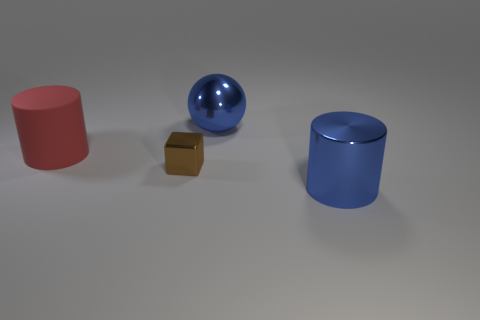There is a big metallic cylinder; is it the same color as the object behind the big red cylinder?
Make the answer very short. Yes. Is the color of the metal sphere the same as the shiny cylinder?
Offer a terse response. Yes. Is there any other thing that has the same size as the brown object?
Ensure brevity in your answer.  No. There is a big blue object that is in front of the blue object behind the large blue metallic object in front of the brown thing; what is its shape?
Your answer should be compact. Cylinder. How many other things are there of the same color as the big sphere?
Offer a terse response. 1. The large blue object on the left side of the blue object in front of the tiny brown metallic block is what shape?
Provide a short and direct response. Sphere. There is a brown shiny thing; what number of big blue cylinders are behind it?
Provide a short and direct response. 0. Is there another red thing made of the same material as the red object?
Give a very brief answer. No. There is a red object that is the same size as the blue cylinder; what material is it?
Provide a succinct answer. Rubber. There is a shiny thing that is right of the brown metallic thing and in front of the red cylinder; what size is it?
Your answer should be very brief. Large. 